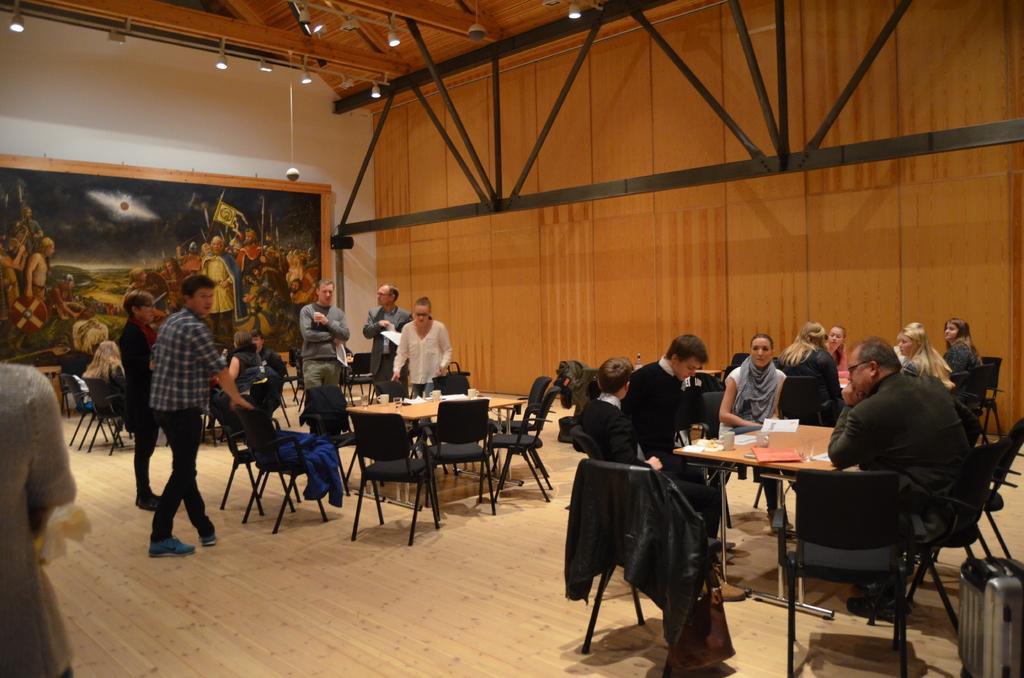In one or two sentences, can you explain what this image depicts? In the image we can see there are people who are sitting on chair and few people are standing. At the back there is a wall on which there is big photo frame. 